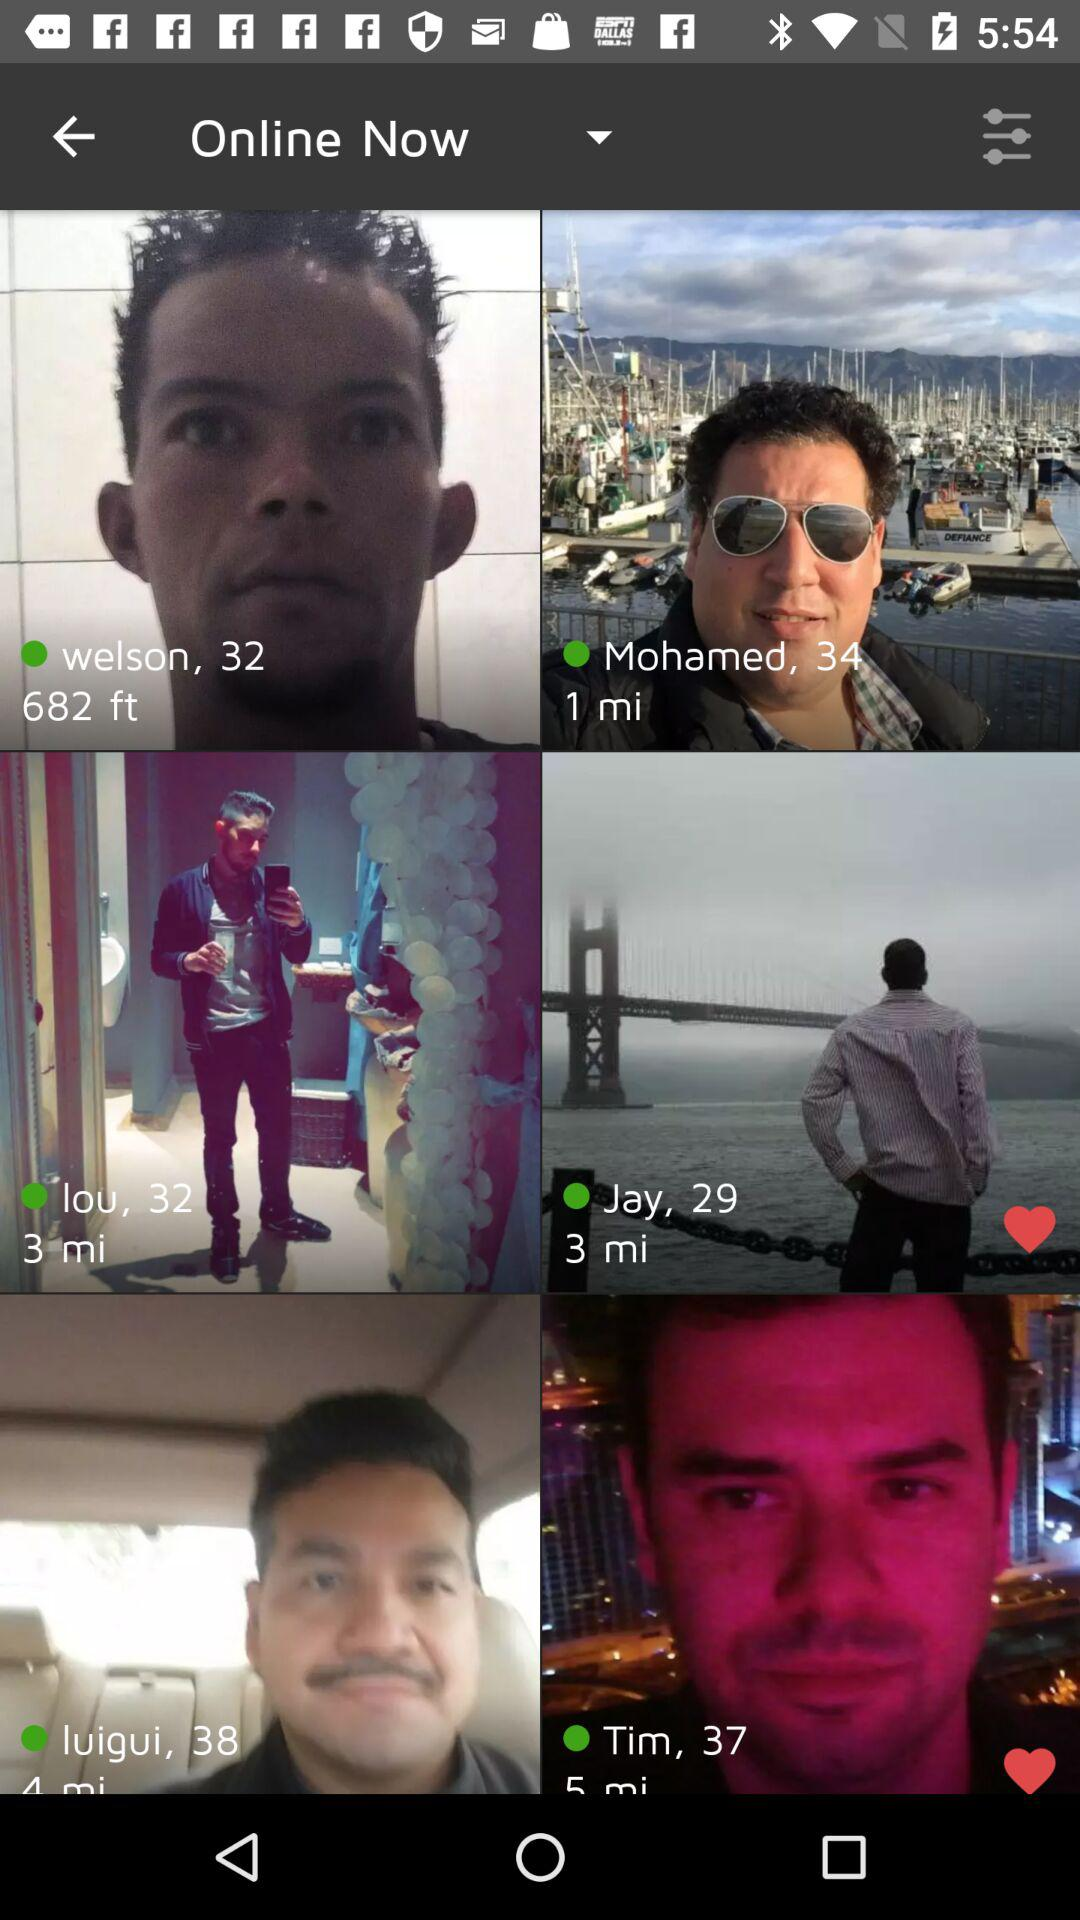What is the age of Tim? The age is 37. 